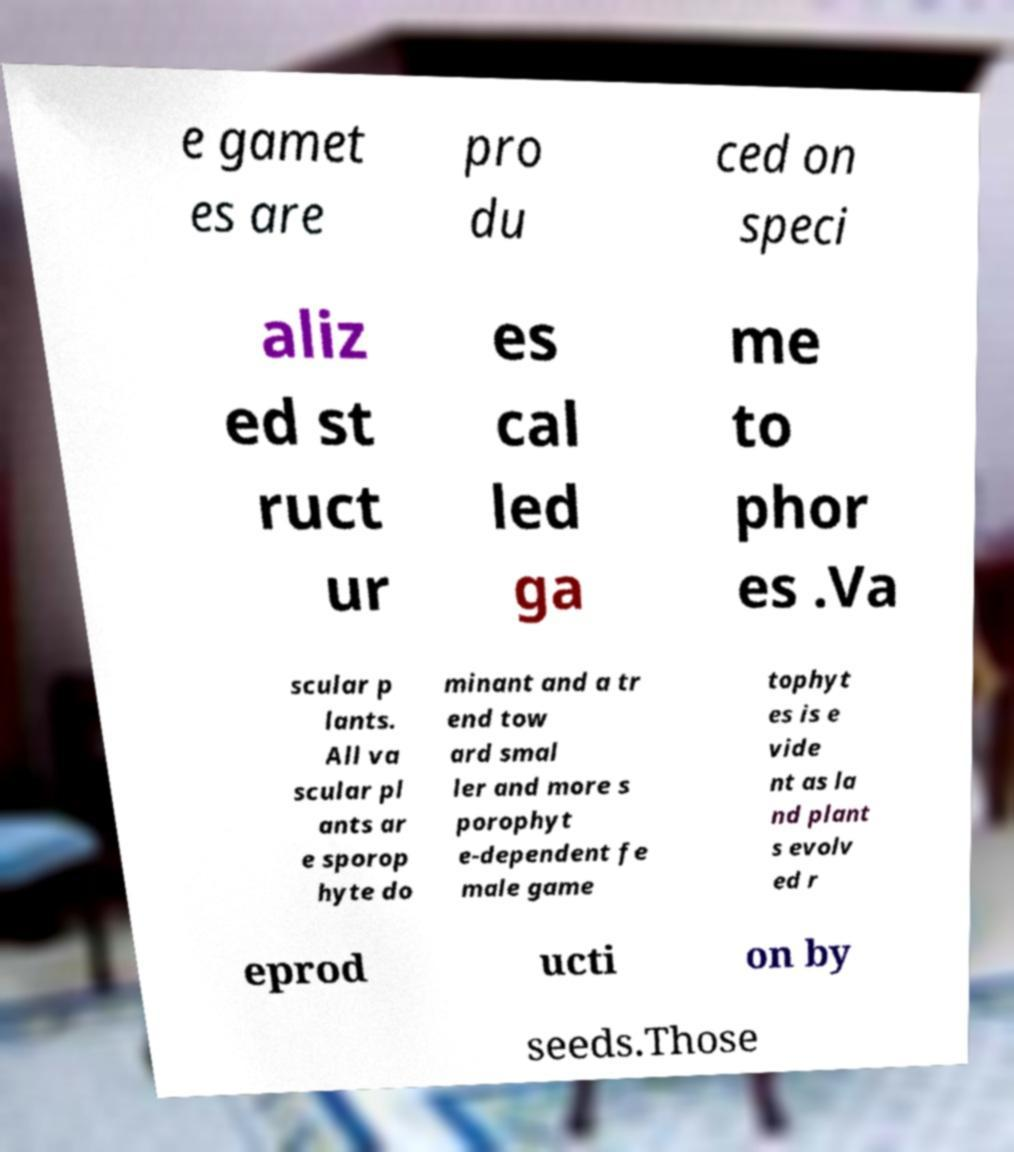For documentation purposes, I need the text within this image transcribed. Could you provide that? e gamet es are pro du ced on speci aliz ed st ruct ur es cal led ga me to phor es .Va scular p lants. All va scular pl ants ar e sporop hyte do minant and a tr end tow ard smal ler and more s porophyt e-dependent fe male game tophyt es is e vide nt as la nd plant s evolv ed r eprod ucti on by seeds.Those 